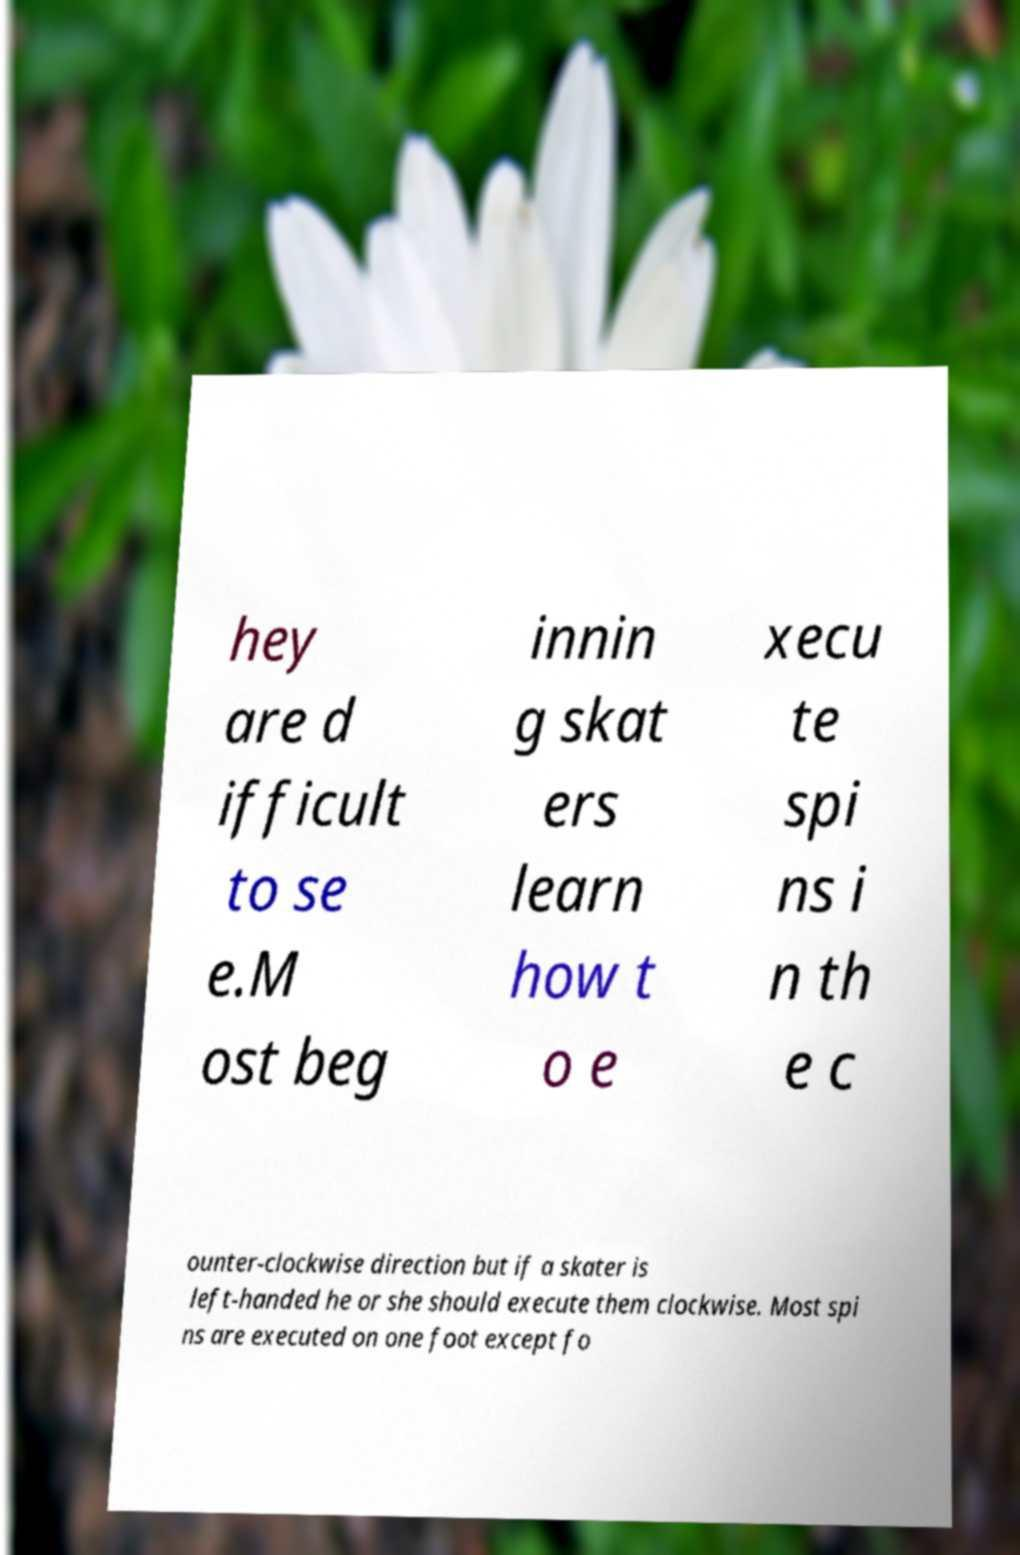Could you extract and type out the text from this image? hey are d ifficult to se e.M ost beg innin g skat ers learn how t o e xecu te spi ns i n th e c ounter-clockwise direction but if a skater is left-handed he or she should execute them clockwise. Most spi ns are executed on one foot except fo 